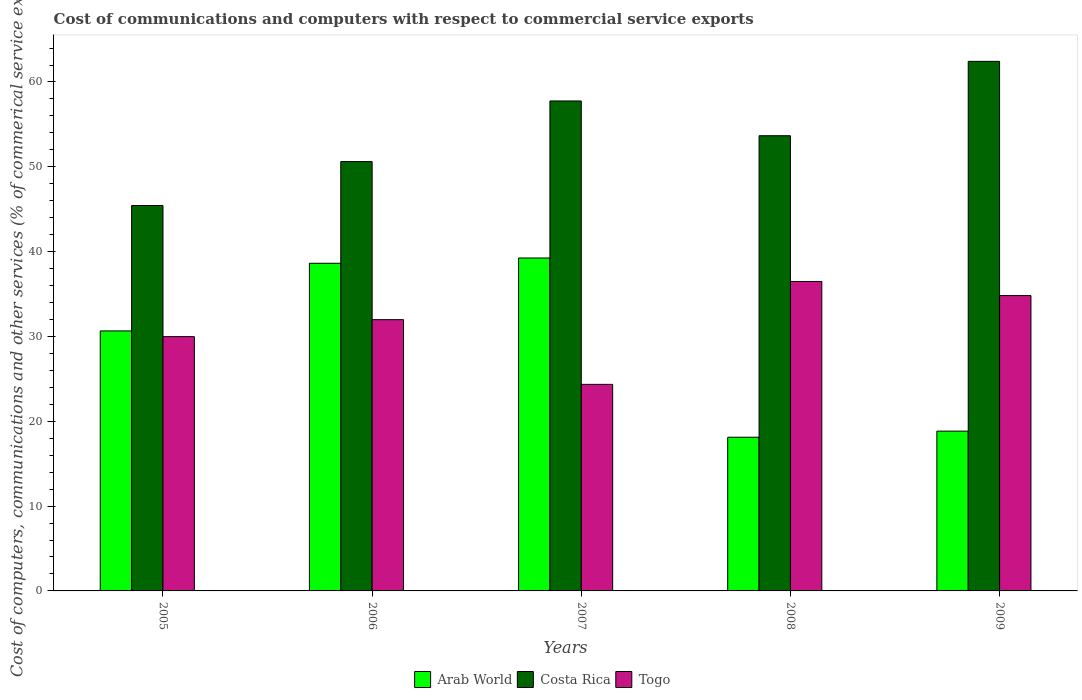How many different coloured bars are there?
Your answer should be very brief. 3. Are the number of bars on each tick of the X-axis equal?
Provide a short and direct response. Yes. How many bars are there on the 1st tick from the left?
Your answer should be very brief. 3. How many bars are there on the 5th tick from the right?
Ensure brevity in your answer.  3. In how many cases, is the number of bars for a given year not equal to the number of legend labels?
Offer a terse response. 0. What is the cost of communications and computers in Togo in 2007?
Ensure brevity in your answer.  24.35. Across all years, what is the maximum cost of communications and computers in Arab World?
Provide a short and direct response. 39.25. Across all years, what is the minimum cost of communications and computers in Costa Rica?
Provide a short and direct response. 45.44. In which year was the cost of communications and computers in Arab World minimum?
Provide a short and direct response. 2008. What is the total cost of communications and computers in Costa Rica in the graph?
Make the answer very short. 269.91. What is the difference between the cost of communications and computers in Togo in 2007 and that in 2009?
Make the answer very short. -10.47. What is the difference between the cost of communications and computers in Arab World in 2005 and the cost of communications and computers in Costa Rica in 2009?
Give a very brief answer. -31.78. What is the average cost of communications and computers in Arab World per year?
Offer a terse response. 29.1. In the year 2009, what is the difference between the cost of communications and computers in Costa Rica and cost of communications and computers in Arab World?
Ensure brevity in your answer.  43.59. In how many years, is the cost of communications and computers in Arab World greater than 60 %?
Provide a short and direct response. 0. What is the ratio of the cost of communications and computers in Costa Rica in 2006 to that in 2008?
Your answer should be very brief. 0.94. Is the cost of communications and computers in Togo in 2007 less than that in 2009?
Offer a terse response. Yes. What is the difference between the highest and the second highest cost of communications and computers in Arab World?
Your answer should be very brief. 0.62. What is the difference between the highest and the lowest cost of communications and computers in Arab World?
Your answer should be very brief. 21.13. What does the 1st bar from the left in 2005 represents?
Ensure brevity in your answer.  Arab World. What does the 1st bar from the right in 2007 represents?
Your answer should be compact. Togo. Is it the case that in every year, the sum of the cost of communications and computers in Togo and cost of communications and computers in Costa Rica is greater than the cost of communications and computers in Arab World?
Give a very brief answer. Yes. Are the values on the major ticks of Y-axis written in scientific E-notation?
Your answer should be very brief. No. Does the graph contain grids?
Ensure brevity in your answer.  No. Where does the legend appear in the graph?
Give a very brief answer. Bottom center. What is the title of the graph?
Make the answer very short. Cost of communications and computers with respect to commercial service exports. Does "Nigeria" appear as one of the legend labels in the graph?
Offer a very short reply. No. What is the label or title of the Y-axis?
Provide a succinct answer. Cost of computers, communications and other services (% of commerical service exports). What is the Cost of computers, communications and other services (% of commerical service exports) of Arab World in 2005?
Offer a very short reply. 30.65. What is the Cost of computers, communications and other services (% of commerical service exports) of Costa Rica in 2005?
Ensure brevity in your answer.  45.44. What is the Cost of computers, communications and other services (% of commerical service exports) in Togo in 2005?
Give a very brief answer. 29.98. What is the Cost of computers, communications and other services (% of commerical service exports) in Arab World in 2006?
Your response must be concise. 38.63. What is the Cost of computers, communications and other services (% of commerical service exports) in Costa Rica in 2006?
Offer a terse response. 50.61. What is the Cost of computers, communications and other services (% of commerical service exports) of Togo in 2006?
Your answer should be compact. 31.98. What is the Cost of computers, communications and other services (% of commerical service exports) of Arab World in 2007?
Give a very brief answer. 39.25. What is the Cost of computers, communications and other services (% of commerical service exports) in Costa Rica in 2007?
Offer a very short reply. 57.76. What is the Cost of computers, communications and other services (% of commerical service exports) of Togo in 2007?
Give a very brief answer. 24.35. What is the Cost of computers, communications and other services (% of commerical service exports) of Arab World in 2008?
Make the answer very short. 18.12. What is the Cost of computers, communications and other services (% of commerical service exports) in Costa Rica in 2008?
Give a very brief answer. 53.66. What is the Cost of computers, communications and other services (% of commerical service exports) in Togo in 2008?
Your response must be concise. 36.48. What is the Cost of computers, communications and other services (% of commerical service exports) in Arab World in 2009?
Make the answer very short. 18.84. What is the Cost of computers, communications and other services (% of commerical service exports) in Costa Rica in 2009?
Provide a short and direct response. 62.43. What is the Cost of computers, communications and other services (% of commerical service exports) of Togo in 2009?
Make the answer very short. 34.82. Across all years, what is the maximum Cost of computers, communications and other services (% of commerical service exports) in Arab World?
Make the answer very short. 39.25. Across all years, what is the maximum Cost of computers, communications and other services (% of commerical service exports) of Costa Rica?
Your answer should be compact. 62.43. Across all years, what is the maximum Cost of computers, communications and other services (% of commerical service exports) in Togo?
Provide a short and direct response. 36.48. Across all years, what is the minimum Cost of computers, communications and other services (% of commerical service exports) in Arab World?
Make the answer very short. 18.12. Across all years, what is the minimum Cost of computers, communications and other services (% of commerical service exports) in Costa Rica?
Make the answer very short. 45.44. Across all years, what is the minimum Cost of computers, communications and other services (% of commerical service exports) of Togo?
Your response must be concise. 24.35. What is the total Cost of computers, communications and other services (% of commerical service exports) of Arab World in the graph?
Ensure brevity in your answer.  145.48. What is the total Cost of computers, communications and other services (% of commerical service exports) of Costa Rica in the graph?
Provide a succinct answer. 269.91. What is the total Cost of computers, communications and other services (% of commerical service exports) in Togo in the graph?
Make the answer very short. 157.6. What is the difference between the Cost of computers, communications and other services (% of commerical service exports) in Arab World in 2005 and that in 2006?
Your answer should be very brief. -7.98. What is the difference between the Cost of computers, communications and other services (% of commerical service exports) in Costa Rica in 2005 and that in 2006?
Keep it short and to the point. -5.18. What is the difference between the Cost of computers, communications and other services (% of commerical service exports) in Togo in 2005 and that in 2006?
Give a very brief answer. -2. What is the difference between the Cost of computers, communications and other services (% of commerical service exports) of Arab World in 2005 and that in 2007?
Your answer should be compact. -8.6. What is the difference between the Cost of computers, communications and other services (% of commerical service exports) in Costa Rica in 2005 and that in 2007?
Offer a terse response. -12.32. What is the difference between the Cost of computers, communications and other services (% of commerical service exports) in Togo in 2005 and that in 2007?
Your answer should be compact. 5.63. What is the difference between the Cost of computers, communications and other services (% of commerical service exports) of Arab World in 2005 and that in 2008?
Keep it short and to the point. 12.53. What is the difference between the Cost of computers, communications and other services (% of commerical service exports) in Costa Rica in 2005 and that in 2008?
Keep it short and to the point. -8.23. What is the difference between the Cost of computers, communications and other services (% of commerical service exports) of Togo in 2005 and that in 2008?
Offer a very short reply. -6.5. What is the difference between the Cost of computers, communications and other services (% of commerical service exports) in Arab World in 2005 and that in 2009?
Your answer should be compact. 11.81. What is the difference between the Cost of computers, communications and other services (% of commerical service exports) in Costa Rica in 2005 and that in 2009?
Ensure brevity in your answer.  -16.99. What is the difference between the Cost of computers, communications and other services (% of commerical service exports) in Togo in 2005 and that in 2009?
Make the answer very short. -4.84. What is the difference between the Cost of computers, communications and other services (% of commerical service exports) in Arab World in 2006 and that in 2007?
Your answer should be compact. -0.62. What is the difference between the Cost of computers, communications and other services (% of commerical service exports) in Costa Rica in 2006 and that in 2007?
Your response must be concise. -7.15. What is the difference between the Cost of computers, communications and other services (% of commerical service exports) of Togo in 2006 and that in 2007?
Provide a succinct answer. 7.63. What is the difference between the Cost of computers, communications and other services (% of commerical service exports) of Arab World in 2006 and that in 2008?
Provide a succinct answer. 20.51. What is the difference between the Cost of computers, communications and other services (% of commerical service exports) in Costa Rica in 2006 and that in 2008?
Provide a succinct answer. -3.05. What is the difference between the Cost of computers, communications and other services (% of commerical service exports) in Togo in 2006 and that in 2008?
Make the answer very short. -4.5. What is the difference between the Cost of computers, communications and other services (% of commerical service exports) of Arab World in 2006 and that in 2009?
Your answer should be very brief. 19.79. What is the difference between the Cost of computers, communications and other services (% of commerical service exports) in Costa Rica in 2006 and that in 2009?
Offer a very short reply. -11.82. What is the difference between the Cost of computers, communications and other services (% of commerical service exports) of Togo in 2006 and that in 2009?
Offer a very short reply. -2.84. What is the difference between the Cost of computers, communications and other services (% of commerical service exports) in Arab World in 2007 and that in 2008?
Provide a succinct answer. 21.13. What is the difference between the Cost of computers, communications and other services (% of commerical service exports) of Costa Rica in 2007 and that in 2008?
Your answer should be very brief. 4.1. What is the difference between the Cost of computers, communications and other services (% of commerical service exports) in Togo in 2007 and that in 2008?
Offer a terse response. -12.13. What is the difference between the Cost of computers, communications and other services (% of commerical service exports) of Arab World in 2007 and that in 2009?
Your answer should be compact. 20.41. What is the difference between the Cost of computers, communications and other services (% of commerical service exports) in Costa Rica in 2007 and that in 2009?
Offer a terse response. -4.67. What is the difference between the Cost of computers, communications and other services (% of commerical service exports) in Togo in 2007 and that in 2009?
Your answer should be very brief. -10.47. What is the difference between the Cost of computers, communications and other services (% of commerical service exports) in Arab World in 2008 and that in 2009?
Your answer should be compact. -0.72. What is the difference between the Cost of computers, communications and other services (% of commerical service exports) in Costa Rica in 2008 and that in 2009?
Provide a short and direct response. -8.77. What is the difference between the Cost of computers, communications and other services (% of commerical service exports) of Togo in 2008 and that in 2009?
Offer a terse response. 1.66. What is the difference between the Cost of computers, communications and other services (% of commerical service exports) of Arab World in 2005 and the Cost of computers, communications and other services (% of commerical service exports) of Costa Rica in 2006?
Your answer should be compact. -19.96. What is the difference between the Cost of computers, communications and other services (% of commerical service exports) of Arab World in 2005 and the Cost of computers, communications and other services (% of commerical service exports) of Togo in 2006?
Offer a terse response. -1.33. What is the difference between the Cost of computers, communications and other services (% of commerical service exports) of Costa Rica in 2005 and the Cost of computers, communications and other services (% of commerical service exports) of Togo in 2006?
Keep it short and to the point. 13.46. What is the difference between the Cost of computers, communications and other services (% of commerical service exports) in Arab World in 2005 and the Cost of computers, communications and other services (% of commerical service exports) in Costa Rica in 2007?
Offer a terse response. -27.11. What is the difference between the Cost of computers, communications and other services (% of commerical service exports) of Arab World in 2005 and the Cost of computers, communications and other services (% of commerical service exports) of Togo in 2007?
Provide a short and direct response. 6.3. What is the difference between the Cost of computers, communications and other services (% of commerical service exports) of Costa Rica in 2005 and the Cost of computers, communications and other services (% of commerical service exports) of Togo in 2007?
Offer a very short reply. 21.09. What is the difference between the Cost of computers, communications and other services (% of commerical service exports) in Arab World in 2005 and the Cost of computers, communications and other services (% of commerical service exports) in Costa Rica in 2008?
Ensure brevity in your answer.  -23.01. What is the difference between the Cost of computers, communications and other services (% of commerical service exports) of Arab World in 2005 and the Cost of computers, communications and other services (% of commerical service exports) of Togo in 2008?
Provide a short and direct response. -5.83. What is the difference between the Cost of computers, communications and other services (% of commerical service exports) in Costa Rica in 2005 and the Cost of computers, communications and other services (% of commerical service exports) in Togo in 2008?
Provide a short and direct response. 8.96. What is the difference between the Cost of computers, communications and other services (% of commerical service exports) in Arab World in 2005 and the Cost of computers, communications and other services (% of commerical service exports) in Costa Rica in 2009?
Provide a succinct answer. -31.78. What is the difference between the Cost of computers, communications and other services (% of commerical service exports) in Arab World in 2005 and the Cost of computers, communications and other services (% of commerical service exports) in Togo in 2009?
Offer a terse response. -4.17. What is the difference between the Cost of computers, communications and other services (% of commerical service exports) in Costa Rica in 2005 and the Cost of computers, communications and other services (% of commerical service exports) in Togo in 2009?
Ensure brevity in your answer.  10.62. What is the difference between the Cost of computers, communications and other services (% of commerical service exports) in Arab World in 2006 and the Cost of computers, communications and other services (% of commerical service exports) in Costa Rica in 2007?
Your response must be concise. -19.13. What is the difference between the Cost of computers, communications and other services (% of commerical service exports) in Arab World in 2006 and the Cost of computers, communications and other services (% of commerical service exports) in Togo in 2007?
Make the answer very short. 14.28. What is the difference between the Cost of computers, communications and other services (% of commerical service exports) in Costa Rica in 2006 and the Cost of computers, communications and other services (% of commerical service exports) in Togo in 2007?
Your answer should be very brief. 26.26. What is the difference between the Cost of computers, communications and other services (% of commerical service exports) in Arab World in 2006 and the Cost of computers, communications and other services (% of commerical service exports) in Costa Rica in 2008?
Provide a short and direct response. -15.04. What is the difference between the Cost of computers, communications and other services (% of commerical service exports) of Arab World in 2006 and the Cost of computers, communications and other services (% of commerical service exports) of Togo in 2008?
Your response must be concise. 2.15. What is the difference between the Cost of computers, communications and other services (% of commerical service exports) in Costa Rica in 2006 and the Cost of computers, communications and other services (% of commerical service exports) in Togo in 2008?
Your answer should be compact. 14.13. What is the difference between the Cost of computers, communications and other services (% of commerical service exports) of Arab World in 2006 and the Cost of computers, communications and other services (% of commerical service exports) of Costa Rica in 2009?
Offer a terse response. -23.8. What is the difference between the Cost of computers, communications and other services (% of commerical service exports) in Arab World in 2006 and the Cost of computers, communications and other services (% of commerical service exports) in Togo in 2009?
Ensure brevity in your answer.  3.81. What is the difference between the Cost of computers, communications and other services (% of commerical service exports) of Costa Rica in 2006 and the Cost of computers, communications and other services (% of commerical service exports) of Togo in 2009?
Offer a terse response. 15.8. What is the difference between the Cost of computers, communications and other services (% of commerical service exports) in Arab World in 2007 and the Cost of computers, communications and other services (% of commerical service exports) in Costa Rica in 2008?
Your answer should be very brief. -14.41. What is the difference between the Cost of computers, communications and other services (% of commerical service exports) of Arab World in 2007 and the Cost of computers, communications and other services (% of commerical service exports) of Togo in 2008?
Your answer should be compact. 2.77. What is the difference between the Cost of computers, communications and other services (% of commerical service exports) in Costa Rica in 2007 and the Cost of computers, communications and other services (% of commerical service exports) in Togo in 2008?
Ensure brevity in your answer.  21.28. What is the difference between the Cost of computers, communications and other services (% of commerical service exports) in Arab World in 2007 and the Cost of computers, communications and other services (% of commerical service exports) in Costa Rica in 2009?
Your answer should be very brief. -23.18. What is the difference between the Cost of computers, communications and other services (% of commerical service exports) of Arab World in 2007 and the Cost of computers, communications and other services (% of commerical service exports) of Togo in 2009?
Your answer should be compact. 4.43. What is the difference between the Cost of computers, communications and other services (% of commerical service exports) in Costa Rica in 2007 and the Cost of computers, communications and other services (% of commerical service exports) in Togo in 2009?
Ensure brevity in your answer.  22.94. What is the difference between the Cost of computers, communications and other services (% of commerical service exports) in Arab World in 2008 and the Cost of computers, communications and other services (% of commerical service exports) in Costa Rica in 2009?
Ensure brevity in your answer.  -44.31. What is the difference between the Cost of computers, communications and other services (% of commerical service exports) in Arab World in 2008 and the Cost of computers, communications and other services (% of commerical service exports) in Togo in 2009?
Provide a succinct answer. -16.7. What is the difference between the Cost of computers, communications and other services (% of commerical service exports) in Costa Rica in 2008 and the Cost of computers, communications and other services (% of commerical service exports) in Togo in 2009?
Offer a very short reply. 18.85. What is the average Cost of computers, communications and other services (% of commerical service exports) of Arab World per year?
Your answer should be very brief. 29.1. What is the average Cost of computers, communications and other services (% of commerical service exports) of Costa Rica per year?
Make the answer very short. 53.98. What is the average Cost of computers, communications and other services (% of commerical service exports) in Togo per year?
Give a very brief answer. 31.52. In the year 2005, what is the difference between the Cost of computers, communications and other services (% of commerical service exports) in Arab World and Cost of computers, communications and other services (% of commerical service exports) in Costa Rica?
Provide a short and direct response. -14.79. In the year 2005, what is the difference between the Cost of computers, communications and other services (% of commerical service exports) in Arab World and Cost of computers, communications and other services (% of commerical service exports) in Togo?
Your answer should be very brief. 0.67. In the year 2005, what is the difference between the Cost of computers, communications and other services (% of commerical service exports) in Costa Rica and Cost of computers, communications and other services (% of commerical service exports) in Togo?
Keep it short and to the point. 15.46. In the year 2006, what is the difference between the Cost of computers, communications and other services (% of commerical service exports) of Arab World and Cost of computers, communications and other services (% of commerical service exports) of Costa Rica?
Give a very brief answer. -11.99. In the year 2006, what is the difference between the Cost of computers, communications and other services (% of commerical service exports) in Arab World and Cost of computers, communications and other services (% of commerical service exports) in Togo?
Your answer should be compact. 6.65. In the year 2006, what is the difference between the Cost of computers, communications and other services (% of commerical service exports) of Costa Rica and Cost of computers, communications and other services (% of commerical service exports) of Togo?
Ensure brevity in your answer.  18.64. In the year 2007, what is the difference between the Cost of computers, communications and other services (% of commerical service exports) of Arab World and Cost of computers, communications and other services (% of commerical service exports) of Costa Rica?
Provide a succinct answer. -18.51. In the year 2007, what is the difference between the Cost of computers, communications and other services (% of commerical service exports) in Arab World and Cost of computers, communications and other services (% of commerical service exports) in Togo?
Give a very brief answer. 14.9. In the year 2007, what is the difference between the Cost of computers, communications and other services (% of commerical service exports) in Costa Rica and Cost of computers, communications and other services (% of commerical service exports) in Togo?
Keep it short and to the point. 33.41. In the year 2008, what is the difference between the Cost of computers, communications and other services (% of commerical service exports) in Arab World and Cost of computers, communications and other services (% of commerical service exports) in Costa Rica?
Give a very brief answer. -35.55. In the year 2008, what is the difference between the Cost of computers, communications and other services (% of commerical service exports) in Arab World and Cost of computers, communications and other services (% of commerical service exports) in Togo?
Ensure brevity in your answer.  -18.36. In the year 2008, what is the difference between the Cost of computers, communications and other services (% of commerical service exports) in Costa Rica and Cost of computers, communications and other services (% of commerical service exports) in Togo?
Your answer should be very brief. 17.18. In the year 2009, what is the difference between the Cost of computers, communications and other services (% of commerical service exports) in Arab World and Cost of computers, communications and other services (% of commerical service exports) in Costa Rica?
Ensure brevity in your answer.  -43.59. In the year 2009, what is the difference between the Cost of computers, communications and other services (% of commerical service exports) of Arab World and Cost of computers, communications and other services (% of commerical service exports) of Togo?
Keep it short and to the point. -15.98. In the year 2009, what is the difference between the Cost of computers, communications and other services (% of commerical service exports) of Costa Rica and Cost of computers, communications and other services (% of commerical service exports) of Togo?
Keep it short and to the point. 27.61. What is the ratio of the Cost of computers, communications and other services (% of commerical service exports) of Arab World in 2005 to that in 2006?
Give a very brief answer. 0.79. What is the ratio of the Cost of computers, communications and other services (% of commerical service exports) of Costa Rica in 2005 to that in 2006?
Your answer should be very brief. 0.9. What is the ratio of the Cost of computers, communications and other services (% of commerical service exports) of Togo in 2005 to that in 2006?
Your response must be concise. 0.94. What is the ratio of the Cost of computers, communications and other services (% of commerical service exports) in Arab World in 2005 to that in 2007?
Give a very brief answer. 0.78. What is the ratio of the Cost of computers, communications and other services (% of commerical service exports) of Costa Rica in 2005 to that in 2007?
Offer a terse response. 0.79. What is the ratio of the Cost of computers, communications and other services (% of commerical service exports) in Togo in 2005 to that in 2007?
Give a very brief answer. 1.23. What is the ratio of the Cost of computers, communications and other services (% of commerical service exports) of Arab World in 2005 to that in 2008?
Offer a terse response. 1.69. What is the ratio of the Cost of computers, communications and other services (% of commerical service exports) in Costa Rica in 2005 to that in 2008?
Ensure brevity in your answer.  0.85. What is the ratio of the Cost of computers, communications and other services (% of commerical service exports) of Togo in 2005 to that in 2008?
Your answer should be compact. 0.82. What is the ratio of the Cost of computers, communications and other services (% of commerical service exports) of Arab World in 2005 to that in 2009?
Your answer should be very brief. 1.63. What is the ratio of the Cost of computers, communications and other services (% of commerical service exports) in Costa Rica in 2005 to that in 2009?
Ensure brevity in your answer.  0.73. What is the ratio of the Cost of computers, communications and other services (% of commerical service exports) in Togo in 2005 to that in 2009?
Give a very brief answer. 0.86. What is the ratio of the Cost of computers, communications and other services (% of commerical service exports) of Arab World in 2006 to that in 2007?
Your answer should be very brief. 0.98. What is the ratio of the Cost of computers, communications and other services (% of commerical service exports) in Costa Rica in 2006 to that in 2007?
Make the answer very short. 0.88. What is the ratio of the Cost of computers, communications and other services (% of commerical service exports) in Togo in 2006 to that in 2007?
Provide a short and direct response. 1.31. What is the ratio of the Cost of computers, communications and other services (% of commerical service exports) of Arab World in 2006 to that in 2008?
Your answer should be very brief. 2.13. What is the ratio of the Cost of computers, communications and other services (% of commerical service exports) in Costa Rica in 2006 to that in 2008?
Ensure brevity in your answer.  0.94. What is the ratio of the Cost of computers, communications and other services (% of commerical service exports) of Togo in 2006 to that in 2008?
Provide a short and direct response. 0.88. What is the ratio of the Cost of computers, communications and other services (% of commerical service exports) in Arab World in 2006 to that in 2009?
Your answer should be very brief. 2.05. What is the ratio of the Cost of computers, communications and other services (% of commerical service exports) in Costa Rica in 2006 to that in 2009?
Provide a succinct answer. 0.81. What is the ratio of the Cost of computers, communications and other services (% of commerical service exports) of Togo in 2006 to that in 2009?
Give a very brief answer. 0.92. What is the ratio of the Cost of computers, communications and other services (% of commerical service exports) in Arab World in 2007 to that in 2008?
Make the answer very short. 2.17. What is the ratio of the Cost of computers, communications and other services (% of commerical service exports) of Costa Rica in 2007 to that in 2008?
Offer a very short reply. 1.08. What is the ratio of the Cost of computers, communications and other services (% of commerical service exports) in Togo in 2007 to that in 2008?
Your answer should be very brief. 0.67. What is the ratio of the Cost of computers, communications and other services (% of commerical service exports) in Arab World in 2007 to that in 2009?
Provide a short and direct response. 2.08. What is the ratio of the Cost of computers, communications and other services (% of commerical service exports) of Costa Rica in 2007 to that in 2009?
Make the answer very short. 0.93. What is the ratio of the Cost of computers, communications and other services (% of commerical service exports) of Togo in 2007 to that in 2009?
Give a very brief answer. 0.7. What is the ratio of the Cost of computers, communications and other services (% of commerical service exports) in Arab World in 2008 to that in 2009?
Your answer should be very brief. 0.96. What is the ratio of the Cost of computers, communications and other services (% of commerical service exports) of Costa Rica in 2008 to that in 2009?
Make the answer very short. 0.86. What is the ratio of the Cost of computers, communications and other services (% of commerical service exports) of Togo in 2008 to that in 2009?
Offer a terse response. 1.05. What is the difference between the highest and the second highest Cost of computers, communications and other services (% of commerical service exports) of Arab World?
Your response must be concise. 0.62. What is the difference between the highest and the second highest Cost of computers, communications and other services (% of commerical service exports) of Costa Rica?
Make the answer very short. 4.67. What is the difference between the highest and the second highest Cost of computers, communications and other services (% of commerical service exports) in Togo?
Your response must be concise. 1.66. What is the difference between the highest and the lowest Cost of computers, communications and other services (% of commerical service exports) in Arab World?
Offer a very short reply. 21.13. What is the difference between the highest and the lowest Cost of computers, communications and other services (% of commerical service exports) of Costa Rica?
Your answer should be compact. 16.99. What is the difference between the highest and the lowest Cost of computers, communications and other services (% of commerical service exports) of Togo?
Provide a short and direct response. 12.13. 